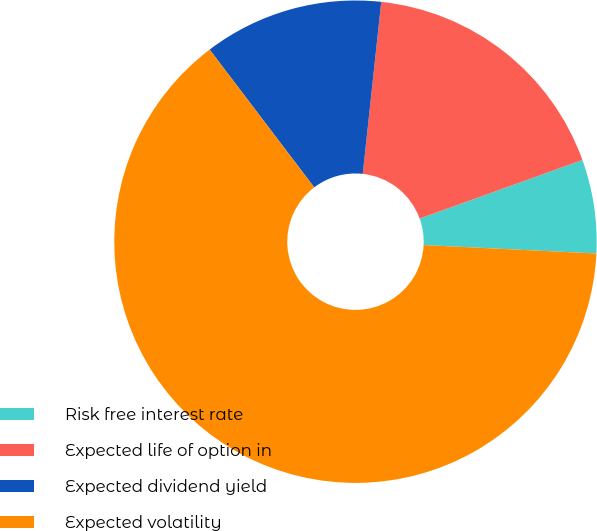<chart> <loc_0><loc_0><loc_500><loc_500><pie_chart><fcel>Risk free interest rate<fcel>Expected life of option in<fcel>Expected dividend yield<fcel>Expected volatility<nl><fcel>6.28%<fcel>17.8%<fcel>12.04%<fcel>63.89%<nl></chart> 